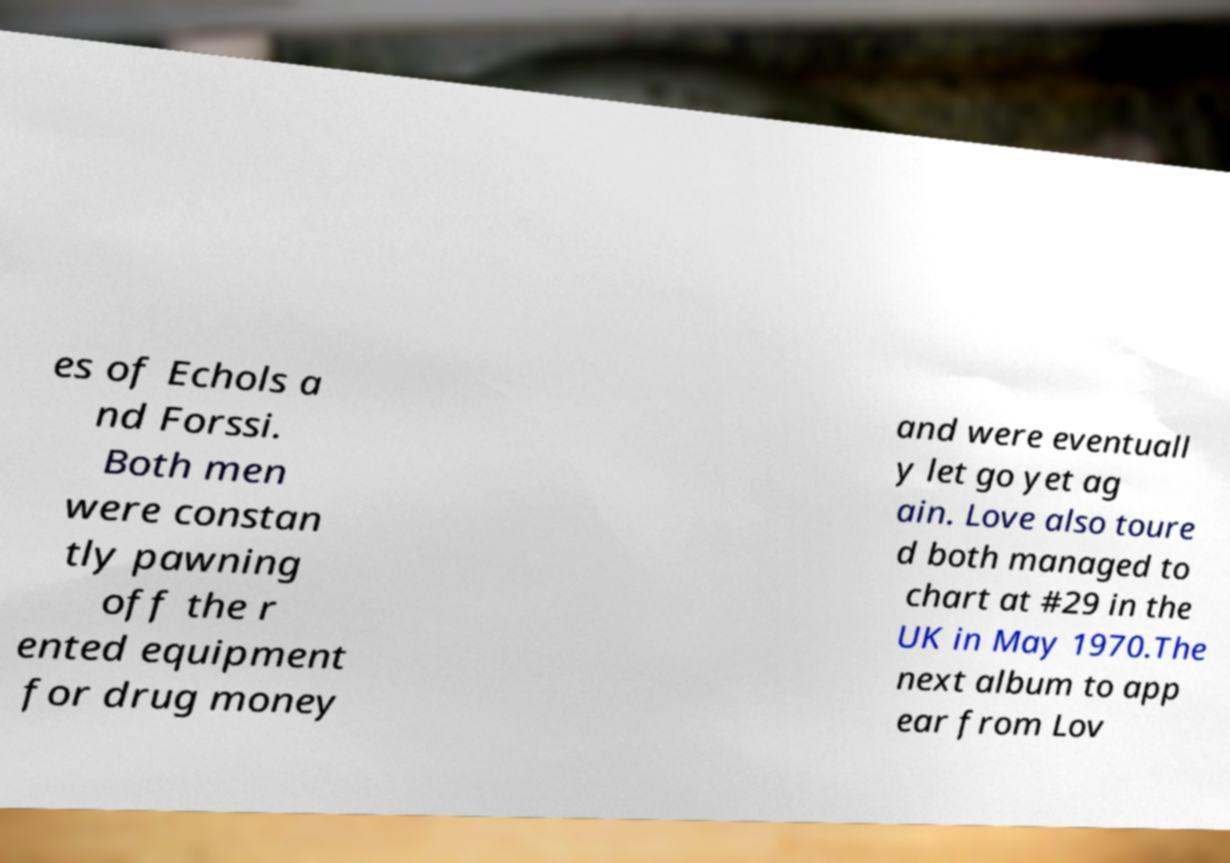I need the written content from this picture converted into text. Can you do that? es of Echols a nd Forssi. Both men were constan tly pawning off the r ented equipment for drug money and were eventuall y let go yet ag ain. Love also toure d both managed to chart at #29 in the UK in May 1970.The next album to app ear from Lov 